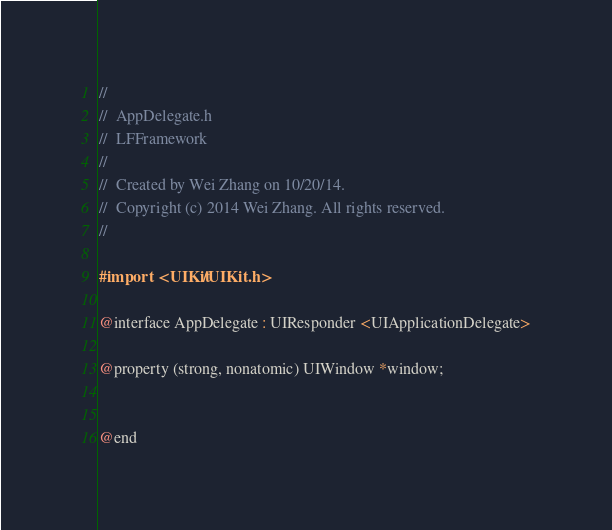<code> <loc_0><loc_0><loc_500><loc_500><_C_>//
//  AppDelegate.h
//  LFFramework
//
//  Created by Wei Zhang on 10/20/14.
//  Copyright (c) 2014 Wei Zhang. All rights reserved.
//

#import <UIKit/UIKit.h>

@interface AppDelegate : UIResponder <UIApplicationDelegate>

@property (strong, nonatomic) UIWindow *window;


@end

</code> 